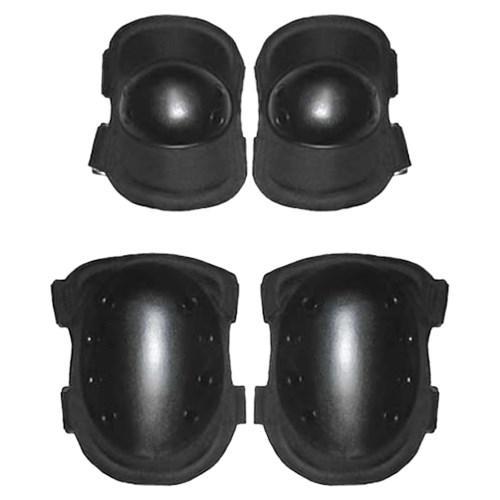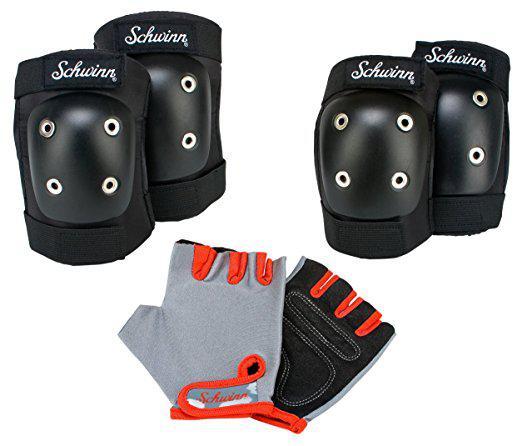The first image is the image on the left, the second image is the image on the right. For the images shown, is this caption "An image includes fingerless gloves and two pairs of pads." true? Answer yes or no. Yes. The first image is the image on the left, the second image is the image on the right. Evaluate the accuracy of this statement regarding the images: "The image on the left has kneepads with only neutral colors such as black and white on it.". Is it true? Answer yes or no. Yes. 